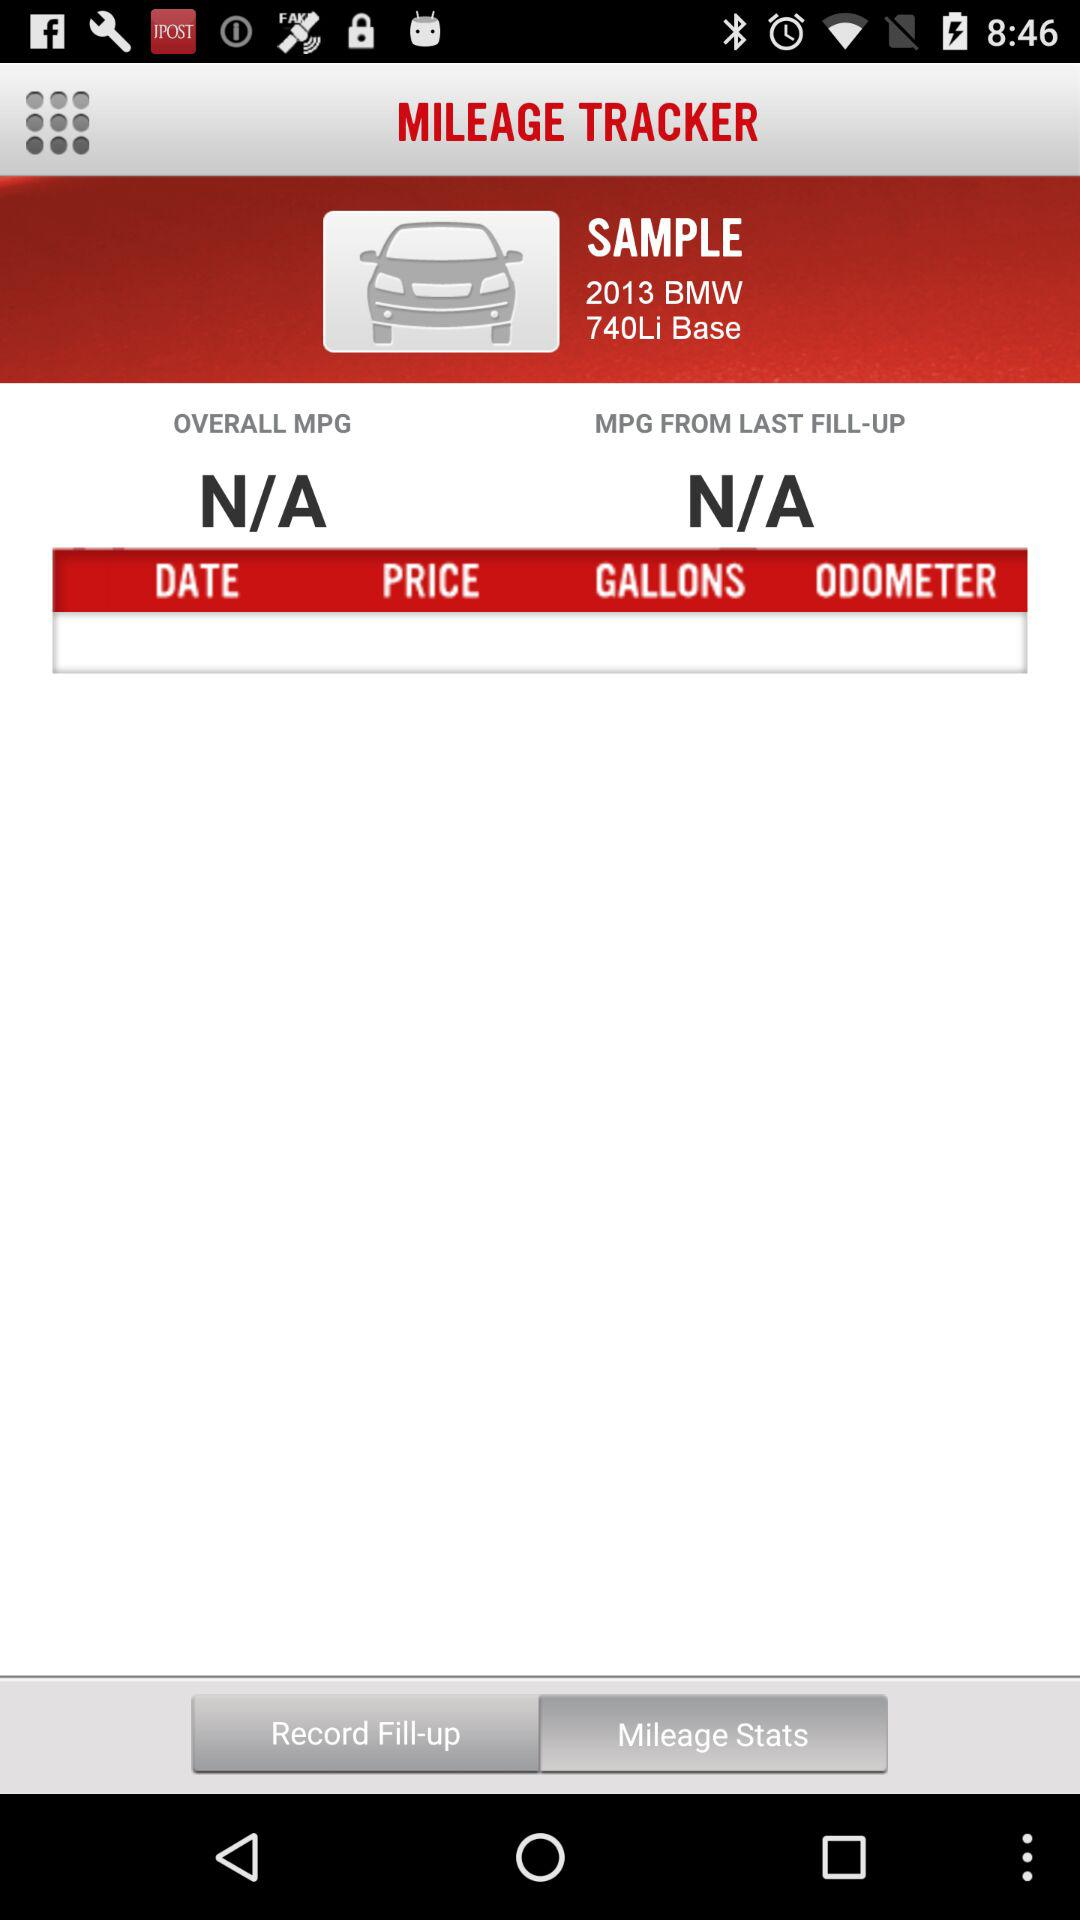Which tab is selected? The selected tab is "Mileage Stats". 